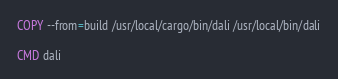<code> <loc_0><loc_0><loc_500><loc_500><_Dockerfile_>
COPY --from=build /usr/local/cargo/bin/dali /usr/local/bin/dali

CMD dali
</code> 